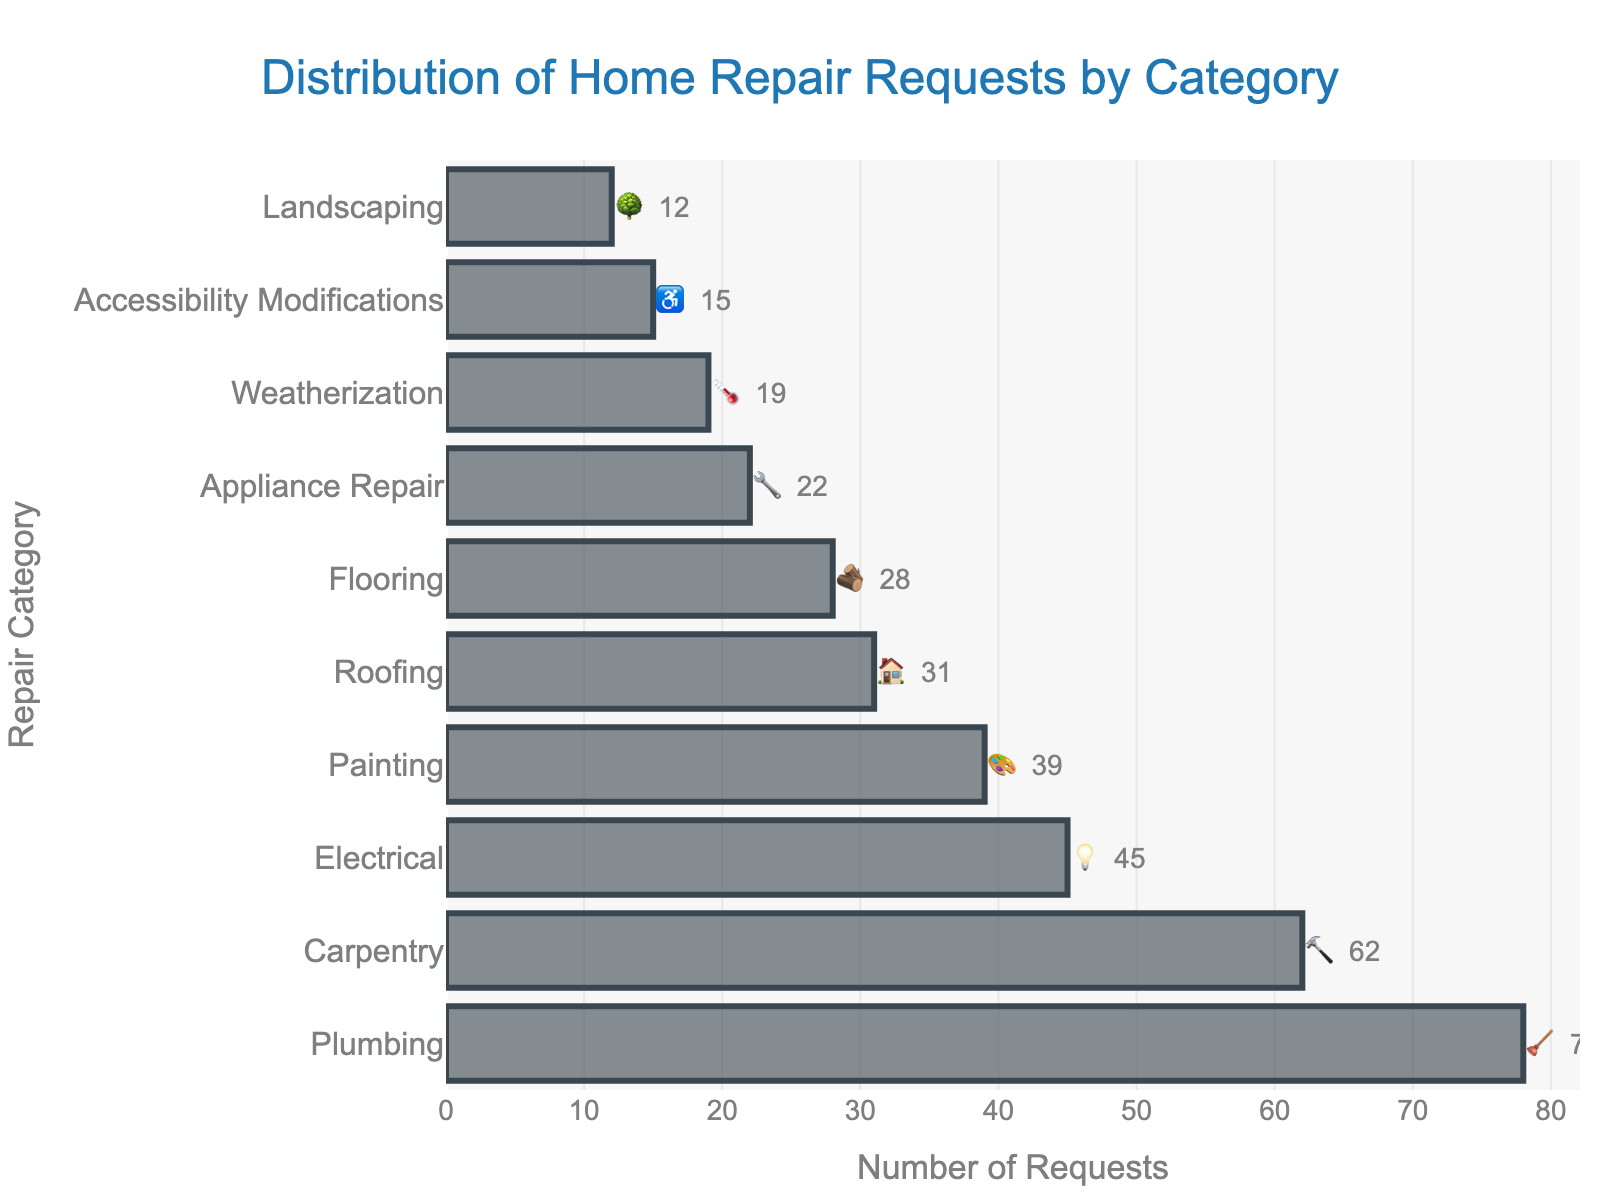What is the title of the chart? The title is located at the top center of the chart.
Answer: Distribution of Home Repair Requests by Category Which category has the highest number of home repair requests? Look for the bar that has the greatest length in the chart.
Answer: Plumbing 🪠 How many requests were made for carpentry repairs? Identify the bar labeled "Carpentry 🔨" and read the value at the end of the bar.
Answer: 62 What is the difference in the number of requests between electrical and appliance repair categories? Subtract the number of requests for Appliance Repair 🔧 (22) from Electrical 💡 (45). 45 - 22 = 23
Answer: 23 What is the combined number of requests for painting and roofing repairs? Add the number of requests for Painting 🎨 (39) and Roofing 🏠 (31). 39 + 31 = 70
Answer: 70 Which category received the fewest number of requests, and what emoji represents it? Find the bar with the smallest length at the bottom of the chart.
Answer: Landscaping 🌳 (12) Are there more requests for flooring or weatherization repairs? Compare the lengths of the bars for Flooring 🪵 (28) and Weatherization 🌡️ (19). Flooring has more requests.
Answer: Flooring 🪵 What is the total number of requests for all categories combined? Sum all the request values: 78 + 62 + 45 + 39 + 31 + 28 + 22 + 19 + 15 + 12 = 351
Answer: 351 What percentage of the total requests does the carpentry category represent? Divide the number of carpentry requests (62) by the total requests (351), then multiply by 100. (62 / 351) * 100 ≈ 17.66%
Answer: 17.66% How many categories have fewer than 30 requests? Count the number of bars representing categories with fewer than 30 requests. These categories are: Appliance Repair 🔧 (22), Weatherization 🌡️ (19), Accessibility Modifications ♿ (15), and Landscaping 🌳 (12).
Answer: 4 